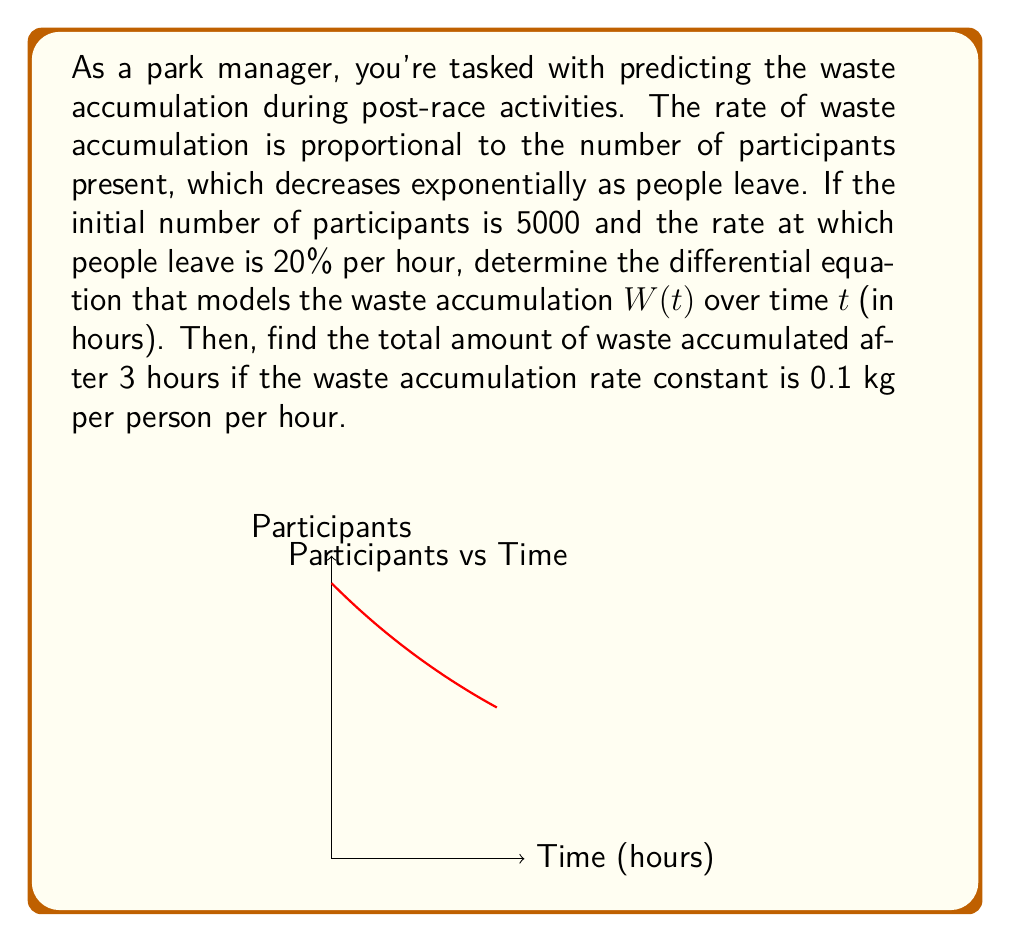Provide a solution to this math problem. Let's approach this step-by-step:

1) First, we need to model the number of participants over time. Given that people are leaving at an exponential rate, we can express this as:

   $P(t) = P_0 e^{-rt}$

   where $P_0 = 5000$ (initial participants) and $r = 0.2$ (rate of leaving per hour).

2) The rate of waste accumulation is proportional to the number of participants. Let's call the proportionality constant $k$. Then we can write:

   $\frac{dW}{dt} = kP(t) = kP_0 e^{-rt}$

3) Substituting the known values:

   $\frac{dW}{dt} = 5000k e^{-0.2t}$

   This is our differential equation for waste accumulation.

4) To find the total waste accumulated, we need to integrate this equation:

   $W(t) = \int_0^t \frac{dW}{dt} dt = \int_0^t 5000k e^{-0.2t} dt$

5) Solving this integral:

   $W(t) = 5000k \cdot \frac{1}{-0.2} \cdot [e^{-0.2t}]_0^t$
   
   $W(t) = -25000k [e^{-0.2t} - 1]$

6) We're given that $k = 0.1$ kg/person/hour and we want to find $W(3)$:

   $W(3) = -25000 \cdot 0.1 [e^{-0.2 \cdot 3} - 1]$
   
   $= -2500 [e^{-0.6} - 1]$
   
   $= -2500 [0.5488 - 1]$
   
   $= 1128$ kg (rounded to nearest kg)
Answer: 1128 kg 